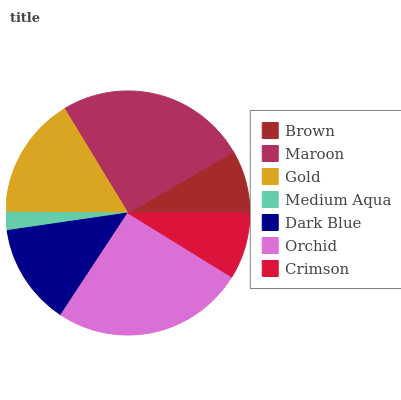Is Medium Aqua the minimum?
Answer yes or no. Yes. Is Orchid the maximum?
Answer yes or no. Yes. Is Maroon the minimum?
Answer yes or no. No. Is Maroon the maximum?
Answer yes or no. No. Is Maroon greater than Brown?
Answer yes or no. Yes. Is Brown less than Maroon?
Answer yes or no. Yes. Is Brown greater than Maroon?
Answer yes or no. No. Is Maroon less than Brown?
Answer yes or no. No. Is Dark Blue the high median?
Answer yes or no. Yes. Is Dark Blue the low median?
Answer yes or no. Yes. Is Medium Aqua the high median?
Answer yes or no. No. Is Gold the low median?
Answer yes or no. No. 